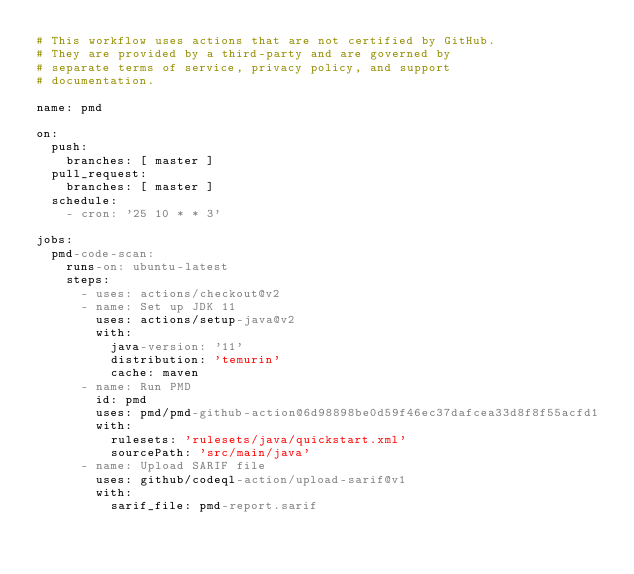<code> <loc_0><loc_0><loc_500><loc_500><_YAML_># This workflow uses actions that are not certified by GitHub.
# They are provided by a third-party and are governed by
# separate terms of service, privacy policy, and support
# documentation.

name: pmd

on:
  push:
    branches: [ master ]
  pull_request:
    branches: [ master ]  
  schedule:
    - cron: '25 10 * * 3'

jobs:
  pmd-code-scan:
    runs-on: ubuntu-latest
    steps:
      - uses: actions/checkout@v2
      - name: Set up JDK 11
        uses: actions/setup-java@v2
        with:
          java-version: '11'
          distribution: 'temurin'
          cache: maven
      - name: Run PMD
        id: pmd
        uses: pmd/pmd-github-action@6d98898be0d59f46ec37dafcea33d8f8f55acfd1
        with:
          rulesets: 'rulesets/java/quickstart.xml'
          sourcePath: 'src/main/java'
      - name: Upload SARIF file
        uses: github/codeql-action/upload-sarif@v1
        with:
          sarif_file: pmd-report.sarif
</code> 